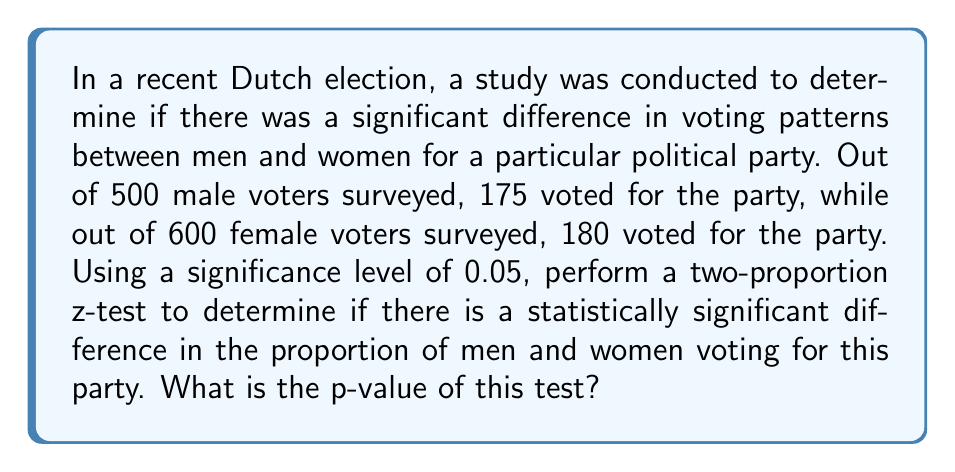Can you solve this math problem? To determine the statistical significance of the gender-based voting patterns, we'll use a two-proportion z-test. Let's follow these steps:

1. Define the null and alternative hypotheses:
   $H_0: p_1 = p_2$ (no difference in proportions)
   $H_a: p_1 \neq p_2$ (there is a difference in proportions)

   Where $p_1$ is the proportion of male voters and $p_2$ is the proportion of female voters.

2. Calculate the sample proportions:
   $\hat{p}_1 = \frac{175}{500} = 0.35$
   $\hat{p}_2 = \frac{180}{600} = 0.30$

3. Calculate the pooled sample proportion:
   $$\hat{p} = \frac{X_1 + X_2}{n_1 + n_2} = \frac{175 + 180}{500 + 600} = \frac{355}{1100} \approx 0.3227$$

4. Calculate the standard error:
   $$SE = \sqrt{\hat{p}(1-\hat{p})(\frac{1}{n_1} + \frac{1}{n_2})}$$
   $$SE = \sqrt{0.3227(1-0.3227)(\frac{1}{500} + \frac{1}{600})} \approx 0.0286$$

5. Calculate the z-statistic:
   $$z = \frac{\hat{p}_1 - \hat{p}_2}{SE} = \frac{0.35 - 0.30}{0.0286} \approx 1.7483$$

6. Calculate the p-value:
   For a two-tailed test, p-value = $2 * P(Z > |z|)$
   Using a standard normal distribution table or calculator:
   p-value $\approx 2 * P(Z > 1.7483) \approx 2 * 0.0402 \approx 0.0804$

The p-value (0.0804) is greater than the significance level (0.05), so we fail to reject the null hypothesis. This suggests that there is not enough evidence to conclude a statistically significant difference in voting patterns between men and women for this party at the 0.05 significance level.
Answer: 0.0804 